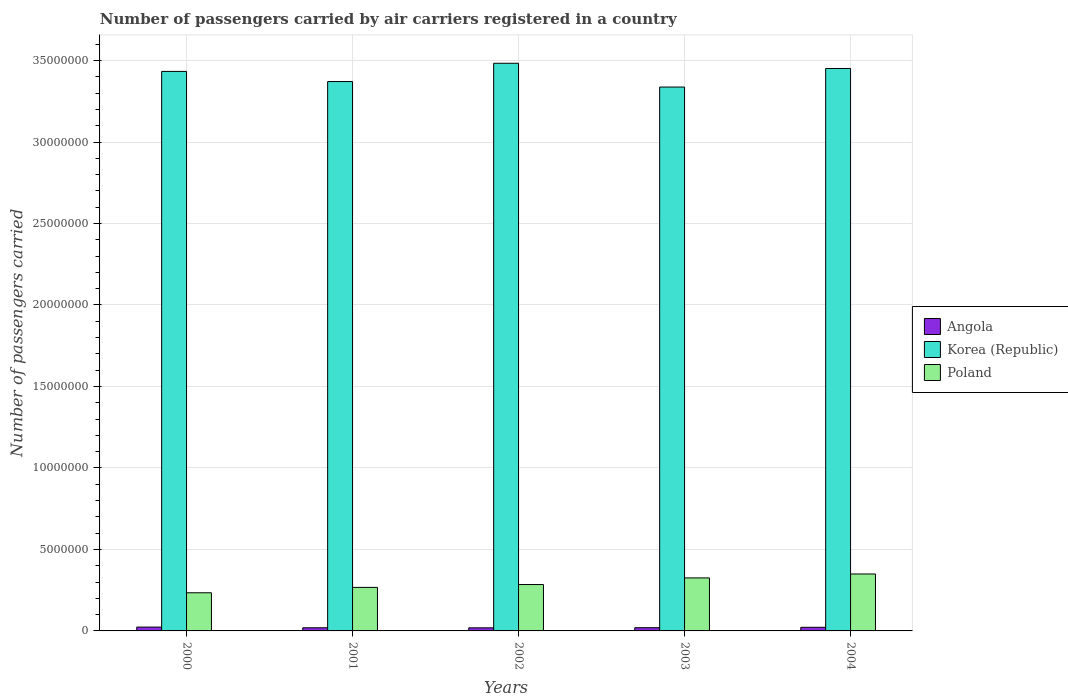How many groups of bars are there?
Your answer should be very brief. 5. Are the number of bars on each tick of the X-axis equal?
Your answer should be compact. Yes. How many bars are there on the 5th tick from the left?
Offer a very short reply. 3. What is the label of the 2nd group of bars from the left?
Your answer should be very brief. 2001. What is the number of passengers carried by air carriers in Korea (Republic) in 2002?
Your answer should be compact. 3.48e+07. Across all years, what is the maximum number of passengers carried by air carriers in Poland?
Offer a terse response. 3.49e+06. Across all years, what is the minimum number of passengers carried by air carriers in Angola?
Give a very brief answer. 1.90e+05. In which year was the number of passengers carried by air carriers in Poland minimum?
Give a very brief answer. 2000. What is the total number of passengers carried by air carriers in Korea (Republic) in the graph?
Keep it short and to the point. 1.71e+08. What is the difference between the number of passengers carried by air carriers in Poland in 2002 and that in 2004?
Your response must be concise. -6.47e+05. What is the difference between the number of passengers carried by air carriers in Poland in 2000 and the number of passengers carried by air carriers in Angola in 2004?
Keep it short and to the point. 2.12e+06. What is the average number of passengers carried by air carriers in Korea (Republic) per year?
Provide a succinct answer. 3.42e+07. In the year 2002, what is the difference between the number of passengers carried by air carriers in Angola and number of passengers carried by air carriers in Korea (Republic)?
Your answer should be very brief. -3.46e+07. What is the ratio of the number of passengers carried by air carriers in Korea (Republic) in 2002 to that in 2003?
Make the answer very short. 1.04. Is the number of passengers carried by air carriers in Poland in 2000 less than that in 2002?
Provide a succinct answer. Yes. What is the difference between the highest and the second highest number of passengers carried by air carriers in Poland?
Give a very brief answer. 2.41e+05. What is the difference between the highest and the lowest number of passengers carried by air carriers in Angola?
Keep it short and to the point. 4.58e+04. Is the sum of the number of passengers carried by air carriers in Poland in 2000 and 2002 greater than the maximum number of passengers carried by air carriers in Angola across all years?
Your answer should be very brief. Yes. What does the 3rd bar from the left in 2003 represents?
Your answer should be very brief. Poland. What does the 3rd bar from the right in 2000 represents?
Give a very brief answer. Angola. How many bars are there?
Keep it short and to the point. 15. How many years are there in the graph?
Your response must be concise. 5. Does the graph contain any zero values?
Give a very brief answer. No. How are the legend labels stacked?
Offer a terse response. Vertical. What is the title of the graph?
Keep it short and to the point. Number of passengers carried by air carriers registered in a country. Does "Mozambique" appear as one of the legend labels in the graph?
Ensure brevity in your answer.  No. What is the label or title of the X-axis?
Offer a very short reply. Years. What is the label or title of the Y-axis?
Give a very brief answer. Number of passengers carried. What is the Number of passengers carried in Angola in 2000?
Ensure brevity in your answer.  2.35e+05. What is the Number of passengers carried in Korea (Republic) in 2000?
Make the answer very short. 3.43e+07. What is the Number of passengers carried in Poland in 2000?
Your response must be concise. 2.34e+06. What is the Number of passengers carried in Angola in 2001?
Offer a terse response. 1.93e+05. What is the Number of passengers carried in Korea (Republic) in 2001?
Give a very brief answer. 3.37e+07. What is the Number of passengers carried in Poland in 2001?
Keep it short and to the point. 2.67e+06. What is the Number of passengers carried of Angola in 2002?
Ensure brevity in your answer.  1.90e+05. What is the Number of passengers carried of Korea (Republic) in 2002?
Your response must be concise. 3.48e+07. What is the Number of passengers carried in Poland in 2002?
Offer a terse response. 2.85e+06. What is the Number of passengers carried in Angola in 2003?
Your answer should be very brief. 1.98e+05. What is the Number of passengers carried of Korea (Republic) in 2003?
Ensure brevity in your answer.  3.34e+07. What is the Number of passengers carried in Poland in 2003?
Offer a terse response. 3.25e+06. What is the Number of passengers carried in Angola in 2004?
Give a very brief answer. 2.22e+05. What is the Number of passengers carried of Korea (Republic) in 2004?
Provide a succinct answer. 3.45e+07. What is the Number of passengers carried in Poland in 2004?
Offer a terse response. 3.49e+06. Across all years, what is the maximum Number of passengers carried in Angola?
Keep it short and to the point. 2.35e+05. Across all years, what is the maximum Number of passengers carried in Korea (Republic)?
Offer a terse response. 3.48e+07. Across all years, what is the maximum Number of passengers carried of Poland?
Provide a succinct answer. 3.49e+06. Across all years, what is the minimum Number of passengers carried of Angola?
Make the answer very short. 1.90e+05. Across all years, what is the minimum Number of passengers carried in Korea (Republic)?
Provide a short and direct response. 3.34e+07. Across all years, what is the minimum Number of passengers carried in Poland?
Provide a succinct answer. 2.34e+06. What is the total Number of passengers carried of Angola in the graph?
Offer a terse response. 1.04e+06. What is the total Number of passengers carried in Korea (Republic) in the graph?
Provide a succinct answer. 1.71e+08. What is the total Number of passengers carried in Poland in the graph?
Keep it short and to the point. 1.46e+07. What is the difference between the Number of passengers carried of Angola in 2000 and that in 2001?
Ensure brevity in your answer.  4.21e+04. What is the difference between the Number of passengers carried of Korea (Republic) in 2000 and that in 2001?
Provide a short and direct response. 6.21e+05. What is the difference between the Number of passengers carried of Poland in 2000 and that in 2001?
Keep it short and to the point. -3.29e+05. What is the difference between the Number of passengers carried in Angola in 2000 and that in 2002?
Make the answer very short. 4.58e+04. What is the difference between the Number of passengers carried of Korea (Republic) in 2000 and that in 2002?
Offer a terse response. -5.00e+05. What is the difference between the Number of passengers carried in Poland in 2000 and that in 2002?
Provide a short and direct response. -5.05e+05. What is the difference between the Number of passengers carried in Angola in 2000 and that in 2003?
Provide a short and direct response. 3.72e+04. What is the difference between the Number of passengers carried of Korea (Republic) in 2000 and that in 2003?
Give a very brief answer. 9.59e+05. What is the difference between the Number of passengers carried of Poland in 2000 and that in 2003?
Make the answer very short. -9.11e+05. What is the difference between the Number of passengers carried of Angola in 2000 and that in 2004?
Keep it short and to the point. 1.34e+04. What is the difference between the Number of passengers carried in Korea (Republic) in 2000 and that in 2004?
Your answer should be very brief. -1.80e+05. What is the difference between the Number of passengers carried in Poland in 2000 and that in 2004?
Give a very brief answer. -1.15e+06. What is the difference between the Number of passengers carried in Angola in 2001 and that in 2002?
Your response must be concise. 3698. What is the difference between the Number of passengers carried of Korea (Republic) in 2001 and that in 2002?
Your response must be concise. -1.12e+06. What is the difference between the Number of passengers carried of Poland in 2001 and that in 2002?
Provide a short and direct response. -1.76e+05. What is the difference between the Number of passengers carried in Angola in 2001 and that in 2003?
Offer a very short reply. -4936. What is the difference between the Number of passengers carried in Korea (Republic) in 2001 and that in 2003?
Provide a short and direct response. 3.38e+05. What is the difference between the Number of passengers carried of Poland in 2001 and that in 2003?
Offer a terse response. -5.82e+05. What is the difference between the Number of passengers carried in Angola in 2001 and that in 2004?
Your answer should be very brief. -2.87e+04. What is the difference between the Number of passengers carried in Korea (Republic) in 2001 and that in 2004?
Provide a short and direct response. -8.01e+05. What is the difference between the Number of passengers carried in Poland in 2001 and that in 2004?
Keep it short and to the point. -8.23e+05. What is the difference between the Number of passengers carried in Angola in 2002 and that in 2003?
Keep it short and to the point. -8634. What is the difference between the Number of passengers carried of Korea (Republic) in 2002 and that in 2003?
Provide a succinct answer. 1.46e+06. What is the difference between the Number of passengers carried in Poland in 2002 and that in 2003?
Give a very brief answer. -4.06e+05. What is the difference between the Number of passengers carried of Angola in 2002 and that in 2004?
Your answer should be very brief. -3.24e+04. What is the difference between the Number of passengers carried of Korea (Republic) in 2002 and that in 2004?
Your answer should be very brief. 3.20e+05. What is the difference between the Number of passengers carried of Poland in 2002 and that in 2004?
Your answer should be compact. -6.47e+05. What is the difference between the Number of passengers carried of Angola in 2003 and that in 2004?
Provide a succinct answer. -2.38e+04. What is the difference between the Number of passengers carried of Korea (Republic) in 2003 and that in 2004?
Provide a short and direct response. -1.14e+06. What is the difference between the Number of passengers carried in Poland in 2003 and that in 2004?
Your answer should be compact. -2.41e+05. What is the difference between the Number of passengers carried in Angola in 2000 and the Number of passengers carried in Korea (Republic) in 2001?
Provide a short and direct response. -3.35e+07. What is the difference between the Number of passengers carried in Angola in 2000 and the Number of passengers carried in Poland in 2001?
Offer a terse response. -2.43e+06. What is the difference between the Number of passengers carried in Korea (Republic) in 2000 and the Number of passengers carried in Poland in 2001?
Give a very brief answer. 3.17e+07. What is the difference between the Number of passengers carried of Angola in 2000 and the Number of passengers carried of Korea (Republic) in 2002?
Your answer should be very brief. -3.46e+07. What is the difference between the Number of passengers carried in Angola in 2000 and the Number of passengers carried in Poland in 2002?
Provide a succinct answer. -2.61e+06. What is the difference between the Number of passengers carried of Korea (Republic) in 2000 and the Number of passengers carried of Poland in 2002?
Provide a short and direct response. 3.15e+07. What is the difference between the Number of passengers carried in Angola in 2000 and the Number of passengers carried in Korea (Republic) in 2003?
Your answer should be very brief. -3.31e+07. What is the difference between the Number of passengers carried of Angola in 2000 and the Number of passengers carried of Poland in 2003?
Your answer should be very brief. -3.02e+06. What is the difference between the Number of passengers carried in Korea (Republic) in 2000 and the Number of passengers carried in Poland in 2003?
Your answer should be compact. 3.11e+07. What is the difference between the Number of passengers carried of Angola in 2000 and the Number of passengers carried of Korea (Republic) in 2004?
Offer a terse response. -3.43e+07. What is the difference between the Number of passengers carried in Angola in 2000 and the Number of passengers carried in Poland in 2004?
Provide a succinct answer. -3.26e+06. What is the difference between the Number of passengers carried of Korea (Republic) in 2000 and the Number of passengers carried of Poland in 2004?
Your response must be concise. 3.08e+07. What is the difference between the Number of passengers carried of Angola in 2001 and the Number of passengers carried of Korea (Republic) in 2002?
Your answer should be very brief. -3.46e+07. What is the difference between the Number of passengers carried in Angola in 2001 and the Number of passengers carried in Poland in 2002?
Provide a succinct answer. -2.65e+06. What is the difference between the Number of passengers carried of Korea (Republic) in 2001 and the Number of passengers carried of Poland in 2002?
Your answer should be compact. 3.09e+07. What is the difference between the Number of passengers carried of Angola in 2001 and the Number of passengers carried of Korea (Republic) in 2003?
Your answer should be compact. -3.32e+07. What is the difference between the Number of passengers carried of Angola in 2001 and the Number of passengers carried of Poland in 2003?
Ensure brevity in your answer.  -3.06e+06. What is the difference between the Number of passengers carried in Korea (Republic) in 2001 and the Number of passengers carried in Poland in 2003?
Give a very brief answer. 3.05e+07. What is the difference between the Number of passengers carried in Angola in 2001 and the Number of passengers carried in Korea (Republic) in 2004?
Ensure brevity in your answer.  -3.43e+07. What is the difference between the Number of passengers carried of Angola in 2001 and the Number of passengers carried of Poland in 2004?
Give a very brief answer. -3.30e+06. What is the difference between the Number of passengers carried of Korea (Republic) in 2001 and the Number of passengers carried of Poland in 2004?
Your answer should be very brief. 3.02e+07. What is the difference between the Number of passengers carried in Angola in 2002 and the Number of passengers carried in Korea (Republic) in 2003?
Provide a short and direct response. -3.32e+07. What is the difference between the Number of passengers carried in Angola in 2002 and the Number of passengers carried in Poland in 2003?
Keep it short and to the point. -3.06e+06. What is the difference between the Number of passengers carried in Korea (Republic) in 2002 and the Number of passengers carried in Poland in 2003?
Provide a short and direct response. 3.16e+07. What is the difference between the Number of passengers carried in Angola in 2002 and the Number of passengers carried in Korea (Republic) in 2004?
Make the answer very short. -3.43e+07. What is the difference between the Number of passengers carried of Angola in 2002 and the Number of passengers carried of Poland in 2004?
Your answer should be compact. -3.30e+06. What is the difference between the Number of passengers carried of Korea (Republic) in 2002 and the Number of passengers carried of Poland in 2004?
Provide a succinct answer. 3.13e+07. What is the difference between the Number of passengers carried in Angola in 2003 and the Number of passengers carried in Korea (Republic) in 2004?
Provide a short and direct response. -3.43e+07. What is the difference between the Number of passengers carried in Angola in 2003 and the Number of passengers carried in Poland in 2004?
Provide a succinct answer. -3.29e+06. What is the difference between the Number of passengers carried of Korea (Republic) in 2003 and the Number of passengers carried of Poland in 2004?
Provide a short and direct response. 2.99e+07. What is the average Number of passengers carried of Angola per year?
Provide a short and direct response. 2.08e+05. What is the average Number of passengers carried of Korea (Republic) per year?
Offer a very short reply. 3.42e+07. What is the average Number of passengers carried of Poland per year?
Offer a very short reply. 2.92e+06. In the year 2000, what is the difference between the Number of passengers carried in Angola and Number of passengers carried in Korea (Republic)?
Keep it short and to the point. -3.41e+07. In the year 2000, what is the difference between the Number of passengers carried in Angola and Number of passengers carried in Poland?
Provide a succinct answer. -2.11e+06. In the year 2000, what is the difference between the Number of passengers carried in Korea (Republic) and Number of passengers carried in Poland?
Offer a very short reply. 3.20e+07. In the year 2001, what is the difference between the Number of passengers carried in Angola and Number of passengers carried in Korea (Republic)?
Offer a very short reply. -3.35e+07. In the year 2001, what is the difference between the Number of passengers carried of Angola and Number of passengers carried of Poland?
Ensure brevity in your answer.  -2.48e+06. In the year 2001, what is the difference between the Number of passengers carried of Korea (Republic) and Number of passengers carried of Poland?
Offer a very short reply. 3.10e+07. In the year 2002, what is the difference between the Number of passengers carried in Angola and Number of passengers carried in Korea (Republic)?
Your answer should be compact. -3.46e+07. In the year 2002, what is the difference between the Number of passengers carried of Angola and Number of passengers carried of Poland?
Give a very brief answer. -2.66e+06. In the year 2002, what is the difference between the Number of passengers carried in Korea (Republic) and Number of passengers carried in Poland?
Offer a terse response. 3.20e+07. In the year 2003, what is the difference between the Number of passengers carried in Angola and Number of passengers carried in Korea (Republic)?
Provide a succinct answer. -3.32e+07. In the year 2003, what is the difference between the Number of passengers carried of Angola and Number of passengers carried of Poland?
Offer a terse response. -3.05e+06. In the year 2003, what is the difference between the Number of passengers carried in Korea (Republic) and Number of passengers carried in Poland?
Give a very brief answer. 3.01e+07. In the year 2004, what is the difference between the Number of passengers carried in Angola and Number of passengers carried in Korea (Republic)?
Provide a succinct answer. -3.43e+07. In the year 2004, what is the difference between the Number of passengers carried in Angola and Number of passengers carried in Poland?
Your response must be concise. -3.27e+06. In the year 2004, what is the difference between the Number of passengers carried of Korea (Republic) and Number of passengers carried of Poland?
Your answer should be very brief. 3.10e+07. What is the ratio of the Number of passengers carried in Angola in 2000 to that in 2001?
Provide a succinct answer. 1.22. What is the ratio of the Number of passengers carried of Korea (Republic) in 2000 to that in 2001?
Give a very brief answer. 1.02. What is the ratio of the Number of passengers carried of Poland in 2000 to that in 2001?
Your answer should be compact. 0.88. What is the ratio of the Number of passengers carried in Angola in 2000 to that in 2002?
Your response must be concise. 1.24. What is the ratio of the Number of passengers carried in Korea (Republic) in 2000 to that in 2002?
Provide a short and direct response. 0.99. What is the ratio of the Number of passengers carried in Poland in 2000 to that in 2002?
Your answer should be compact. 0.82. What is the ratio of the Number of passengers carried in Angola in 2000 to that in 2003?
Provide a short and direct response. 1.19. What is the ratio of the Number of passengers carried in Korea (Republic) in 2000 to that in 2003?
Offer a very short reply. 1.03. What is the ratio of the Number of passengers carried of Poland in 2000 to that in 2003?
Provide a succinct answer. 0.72. What is the ratio of the Number of passengers carried in Angola in 2000 to that in 2004?
Provide a short and direct response. 1.06. What is the ratio of the Number of passengers carried of Korea (Republic) in 2000 to that in 2004?
Give a very brief answer. 0.99. What is the ratio of the Number of passengers carried in Poland in 2000 to that in 2004?
Offer a terse response. 0.67. What is the ratio of the Number of passengers carried of Angola in 2001 to that in 2002?
Offer a terse response. 1.02. What is the ratio of the Number of passengers carried of Korea (Republic) in 2001 to that in 2002?
Your response must be concise. 0.97. What is the ratio of the Number of passengers carried of Poland in 2001 to that in 2002?
Offer a terse response. 0.94. What is the ratio of the Number of passengers carried of Angola in 2001 to that in 2003?
Offer a very short reply. 0.98. What is the ratio of the Number of passengers carried in Korea (Republic) in 2001 to that in 2003?
Offer a very short reply. 1.01. What is the ratio of the Number of passengers carried of Poland in 2001 to that in 2003?
Your answer should be compact. 0.82. What is the ratio of the Number of passengers carried of Angola in 2001 to that in 2004?
Keep it short and to the point. 0.87. What is the ratio of the Number of passengers carried in Korea (Republic) in 2001 to that in 2004?
Offer a very short reply. 0.98. What is the ratio of the Number of passengers carried in Poland in 2001 to that in 2004?
Your answer should be compact. 0.76. What is the ratio of the Number of passengers carried in Angola in 2002 to that in 2003?
Make the answer very short. 0.96. What is the ratio of the Number of passengers carried of Korea (Republic) in 2002 to that in 2003?
Make the answer very short. 1.04. What is the ratio of the Number of passengers carried of Poland in 2002 to that in 2003?
Provide a short and direct response. 0.88. What is the ratio of the Number of passengers carried in Angola in 2002 to that in 2004?
Your response must be concise. 0.85. What is the ratio of the Number of passengers carried in Korea (Republic) in 2002 to that in 2004?
Your response must be concise. 1.01. What is the ratio of the Number of passengers carried in Poland in 2002 to that in 2004?
Make the answer very short. 0.81. What is the ratio of the Number of passengers carried of Angola in 2003 to that in 2004?
Ensure brevity in your answer.  0.89. What is the difference between the highest and the second highest Number of passengers carried in Angola?
Your answer should be very brief. 1.34e+04. What is the difference between the highest and the second highest Number of passengers carried of Korea (Republic)?
Provide a succinct answer. 3.20e+05. What is the difference between the highest and the second highest Number of passengers carried in Poland?
Provide a succinct answer. 2.41e+05. What is the difference between the highest and the lowest Number of passengers carried in Angola?
Your response must be concise. 4.58e+04. What is the difference between the highest and the lowest Number of passengers carried in Korea (Republic)?
Your answer should be compact. 1.46e+06. What is the difference between the highest and the lowest Number of passengers carried in Poland?
Offer a very short reply. 1.15e+06. 